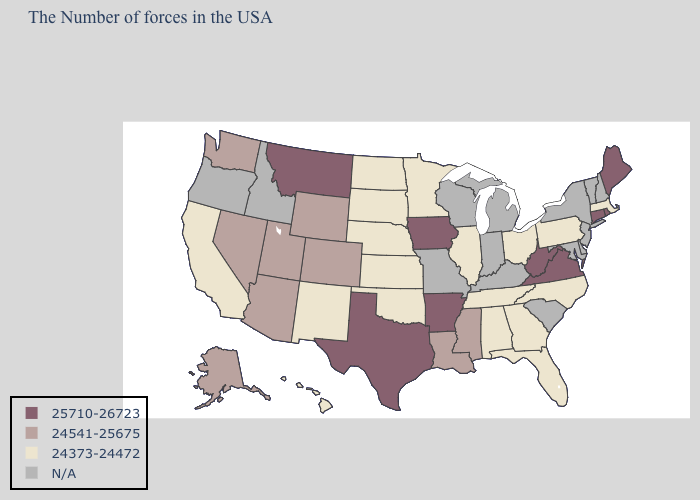Name the states that have a value in the range 24373-24472?
Short answer required. Massachusetts, Pennsylvania, North Carolina, Ohio, Florida, Georgia, Alabama, Tennessee, Illinois, Minnesota, Kansas, Nebraska, Oklahoma, South Dakota, North Dakota, New Mexico, California, Hawaii. What is the lowest value in states that border Wisconsin?
Short answer required. 24373-24472. What is the highest value in the USA?
Concise answer only. 25710-26723. What is the value of Missouri?
Short answer required. N/A. Name the states that have a value in the range 24373-24472?
Give a very brief answer. Massachusetts, Pennsylvania, North Carolina, Ohio, Florida, Georgia, Alabama, Tennessee, Illinois, Minnesota, Kansas, Nebraska, Oklahoma, South Dakota, North Dakota, New Mexico, California, Hawaii. Does Texas have the highest value in the USA?
Give a very brief answer. Yes. What is the lowest value in the USA?
Write a very short answer. 24373-24472. What is the value of Indiana?
Be succinct. N/A. Which states hav the highest value in the South?
Write a very short answer. Virginia, West Virginia, Arkansas, Texas. What is the highest value in the West ?
Quick response, please. 25710-26723. What is the value of Virginia?
Quick response, please. 25710-26723. What is the value of Rhode Island?
Short answer required. 25710-26723. Name the states that have a value in the range 25710-26723?
Be succinct. Maine, Rhode Island, Connecticut, Virginia, West Virginia, Arkansas, Iowa, Texas, Montana. 